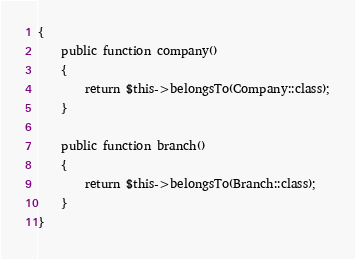<code> <loc_0><loc_0><loc_500><loc_500><_PHP_>{
    public function company()
    {
        return $this->belongsTo(Company::class);
    }

    public function branch()
    {
        return $this->belongsTo(Branch::class);
    }
}
</code> 